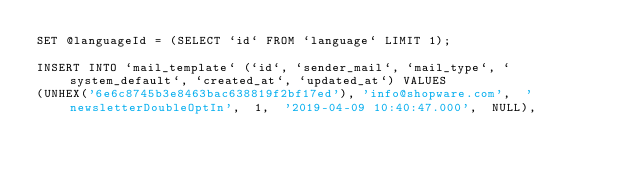<code> <loc_0><loc_0><loc_500><loc_500><_SQL_>SET @languageId = (SELECT `id` FROM `language` LIMIT 1);

INSERT INTO `mail_template` (`id`, `sender_mail`, `mail_type`, `system_default`, `created_at`, `updated_at`) VALUES
(UNHEX('6e6c8745b3e8463bac638819f2bf17ed'),	'info@shopware.com',	'newsletterDoubleOptIn',	1,	'2019-04-09 10:40:47.000',	NULL),</code> 